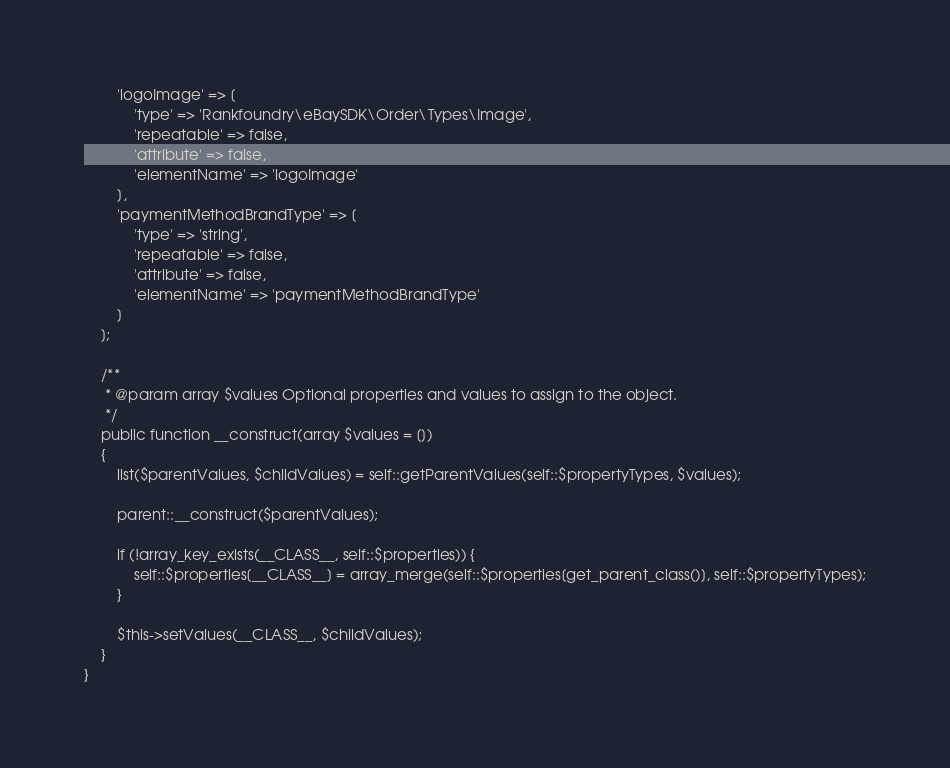<code> <loc_0><loc_0><loc_500><loc_500><_PHP_>        'logoImage' => [
            'type' => 'Rankfoundry\eBaySDK\Order\Types\Image',
            'repeatable' => false,
            'attribute' => false,
            'elementName' => 'logoImage'
        ],
        'paymentMethodBrandType' => [
            'type' => 'string',
            'repeatable' => false,
            'attribute' => false,
            'elementName' => 'paymentMethodBrandType'
        ]
    ];

    /**
     * @param array $values Optional properties and values to assign to the object.
     */
    public function __construct(array $values = [])
    {
        list($parentValues, $childValues) = self::getParentValues(self::$propertyTypes, $values);

        parent::__construct($parentValues);

        if (!array_key_exists(__CLASS__, self::$properties)) {
            self::$properties[__CLASS__] = array_merge(self::$properties[get_parent_class()], self::$propertyTypes);
        }

        $this->setValues(__CLASS__, $childValues);
    }
}
</code> 